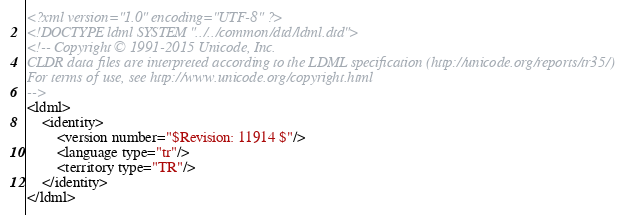<code> <loc_0><loc_0><loc_500><loc_500><_XML_><?xml version="1.0" encoding="UTF-8" ?>
<!DOCTYPE ldml SYSTEM "../../common/dtd/ldml.dtd">
<!-- Copyright © 1991-2015 Unicode, Inc.
CLDR data files are interpreted according to the LDML specification (http://unicode.org/reports/tr35/)
For terms of use, see http://www.unicode.org/copyright.html
-->
<ldml>
	<identity>
		<version number="$Revision: 11914 $"/>
		<language type="tr"/>
		<territory type="TR"/>
	</identity>
</ldml>

</code> 